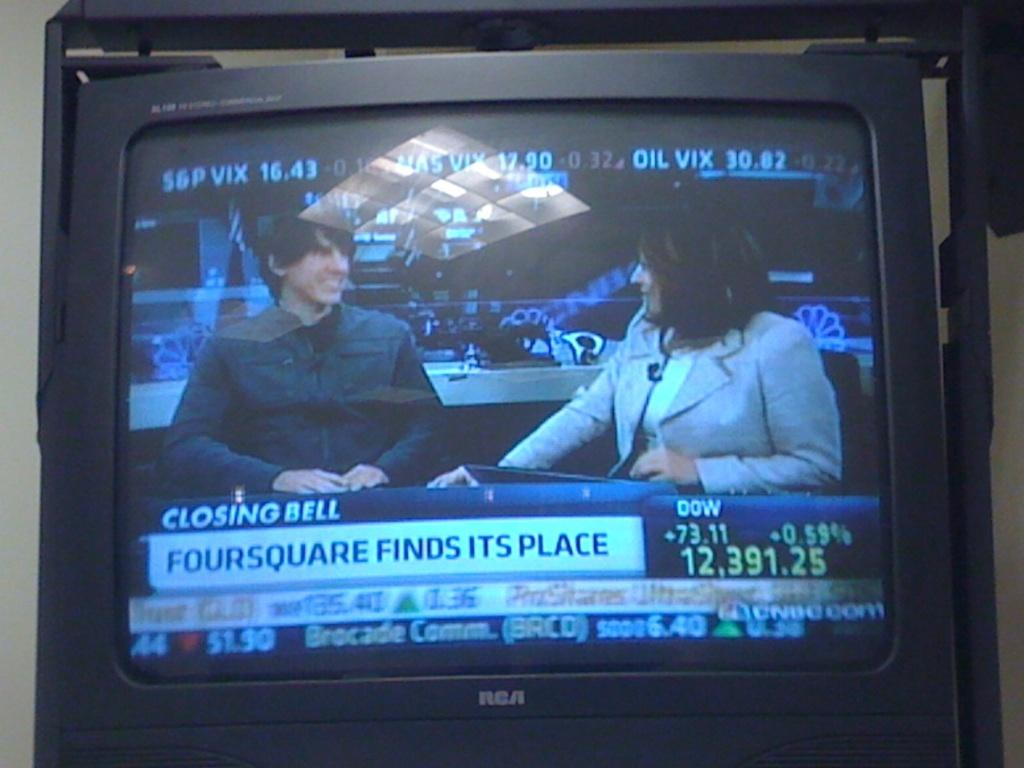<image>
Summarize the visual content of the image. At the closing bell, the Dow went up 73.11 which was an increase of 0.59%. 